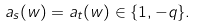<formula> <loc_0><loc_0><loc_500><loc_500>a _ { s } ( w ) = a _ { t } ( w ) \in \{ 1 , - q \} .</formula> 